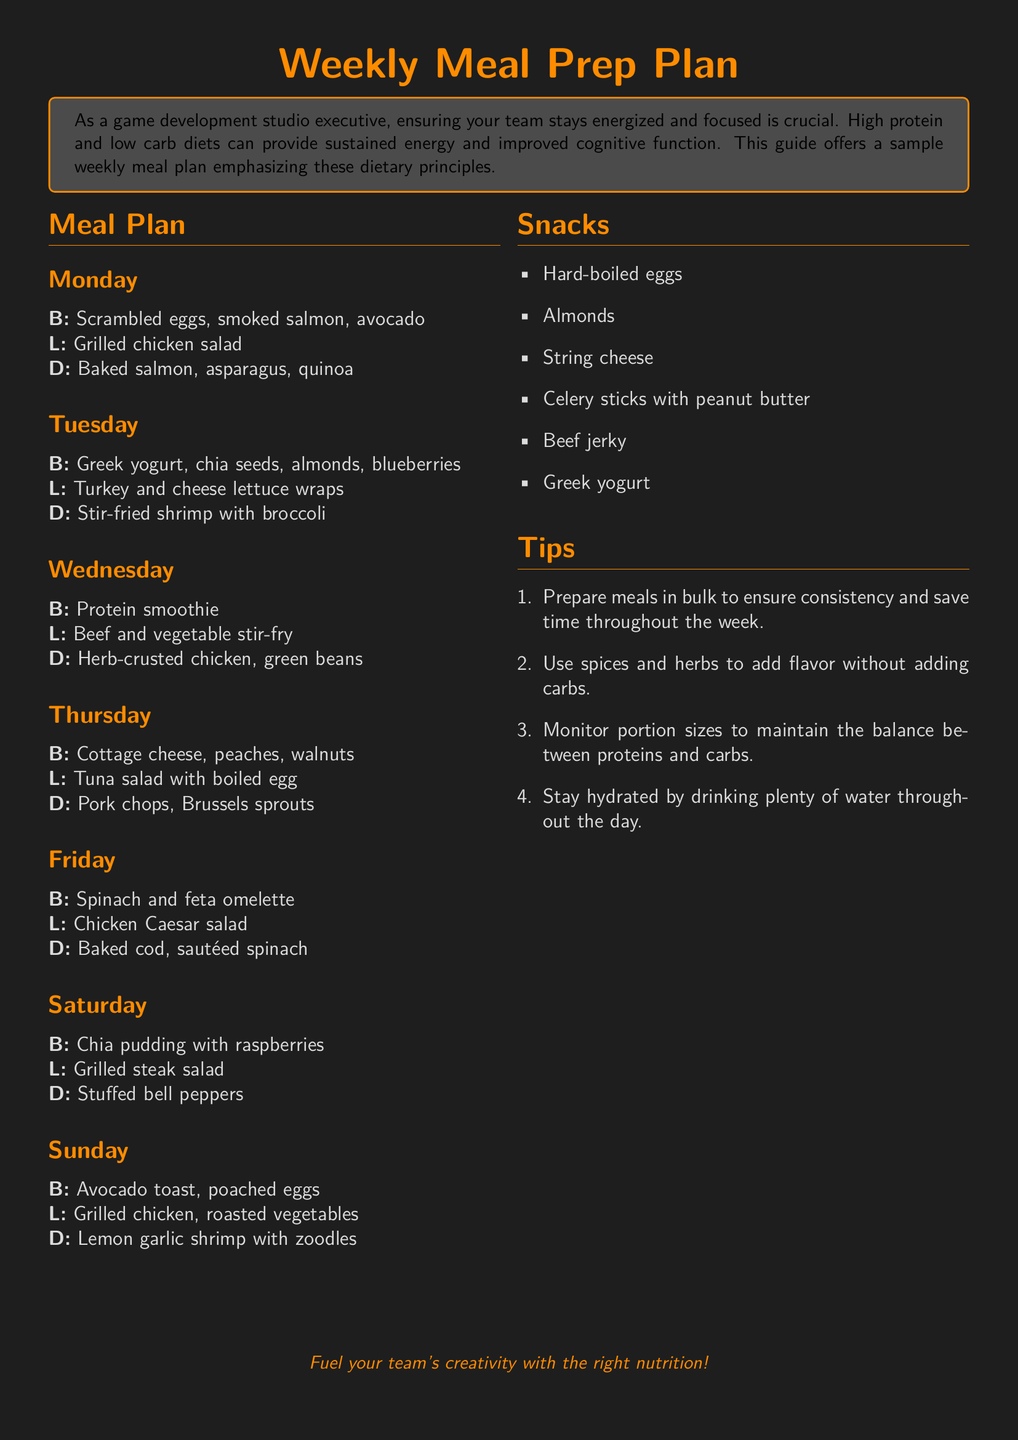What is the main dietary focus of the meal plan? The meal plan emphasizes high protein and low carb diets to keep the team energized.
Answer: high protein and low carb Which day features grilled chicken for lunch? Grilled chicken is served for lunch on Monday and Sunday.
Answer: Monday and Sunday What is the snack item listed that provides protein? The document lists several snacks; one notable high-protein option is beef jerky.
Answer: beef jerky How many meals are suggested for each day? The document suggests three meals for each day of the week.
Answer: three meals What type of salad is included in Tuesday's lunch? The lunch on Tuesday includes turkey and cheese lettuce wraps, which are a type of salad.
Answer: turkey and cheese lettuce wraps What is one tip provided for meal prepping? The document provides several tips, one of which is to prepare meals in bulk to ensure consistency.
Answer: prepare meals in bulk What ingredient is used for the breakfast on Saturday? For breakfast on Saturday, chia pudding is suggested with raspberries.
Answer: chia pudding Which vegetable is paired with baked cod for dinner? The dinner on Friday includes sautéed spinach as a side with baked cod.
Answer: sautéed spinach What is the suggested beverage to maintain hydration throughout the day? The document doesn't specify a unique beverage, but it emphasizes drinking plenty of water to stay hydrated.
Answer: water 